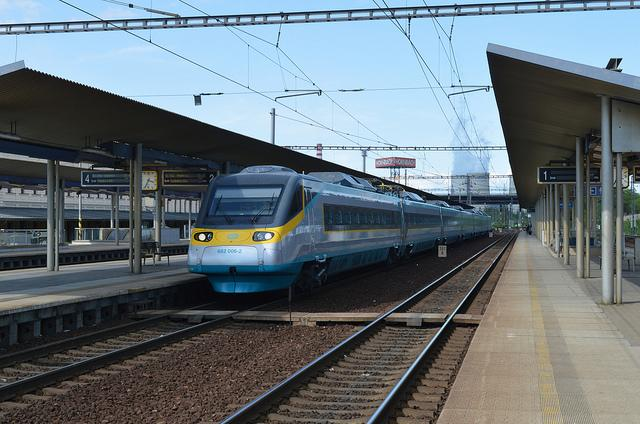What is the item closest to the green sign on the left that has the number 4 on it?

Choices:
A) train
B) track
C) briefcase
D) clock clock 